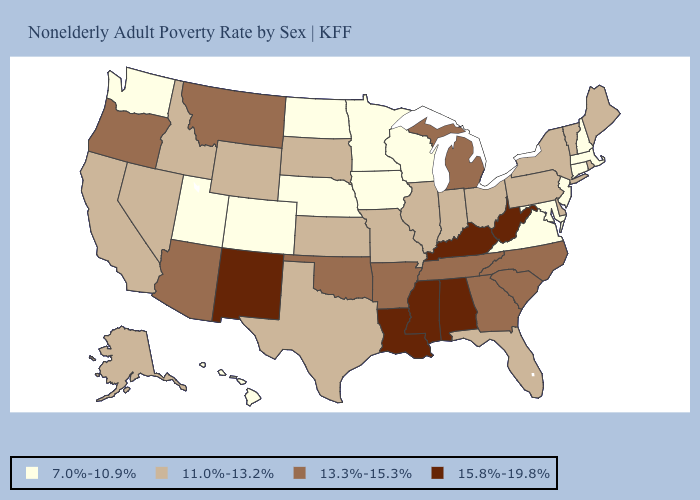Does North Carolina have the same value as Oregon?
Be succinct. Yes. What is the value of Mississippi?
Short answer required. 15.8%-19.8%. What is the value of Utah?
Short answer required. 7.0%-10.9%. What is the highest value in the MidWest ?
Give a very brief answer. 13.3%-15.3%. Name the states that have a value in the range 7.0%-10.9%?
Answer briefly. Colorado, Connecticut, Hawaii, Iowa, Maryland, Massachusetts, Minnesota, Nebraska, New Hampshire, New Jersey, North Dakota, Utah, Virginia, Washington, Wisconsin. Name the states that have a value in the range 7.0%-10.9%?
Write a very short answer. Colorado, Connecticut, Hawaii, Iowa, Maryland, Massachusetts, Minnesota, Nebraska, New Hampshire, New Jersey, North Dakota, Utah, Virginia, Washington, Wisconsin. What is the lowest value in the USA?
Quick response, please. 7.0%-10.9%. What is the value of Missouri?
Keep it brief. 11.0%-13.2%. Does Louisiana have the highest value in the South?
Keep it brief. Yes. Does California have the lowest value in the USA?
Give a very brief answer. No. Name the states that have a value in the range 7.0%-10.9%?
Answer briefly. Colorado, Connecticut, Hawaii, Iowa, Maryland, Massachusetts, Minnesota, Nebraska, New Hampshire, New Jersey, North Dakota, Utah, Virginia, Washington, Wisconsin. What is the value of Iowa?
Give a very brief answer. 7.0%-10.9%. Which states have the highest value in the USA?
Give a very brief answer. Alabama, Kentucky, Louisiana, Mississippi, New Mexico, West Virginia. Does Rhode Island have the lowest value in the Northeast?
Keep it brief. No. 